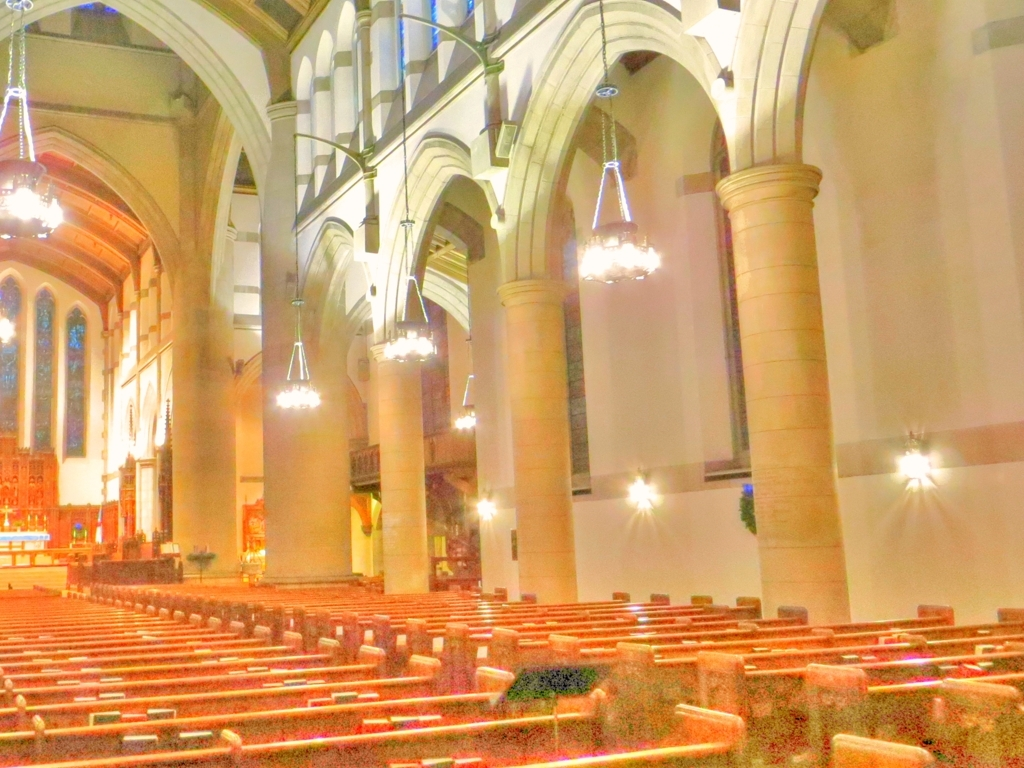Can you describe the architectural style visible in the image? The architecture inside this building is characteristic of Gothic Revival styles, with its pointed arches, a high vaulted ceiling, and elongated windows. Pairs of pillars spaced along the nave support the ceiling, and a sense of verticality is emphasized, typical of the ecclesiastical designs intended to draw the eye upwards. 